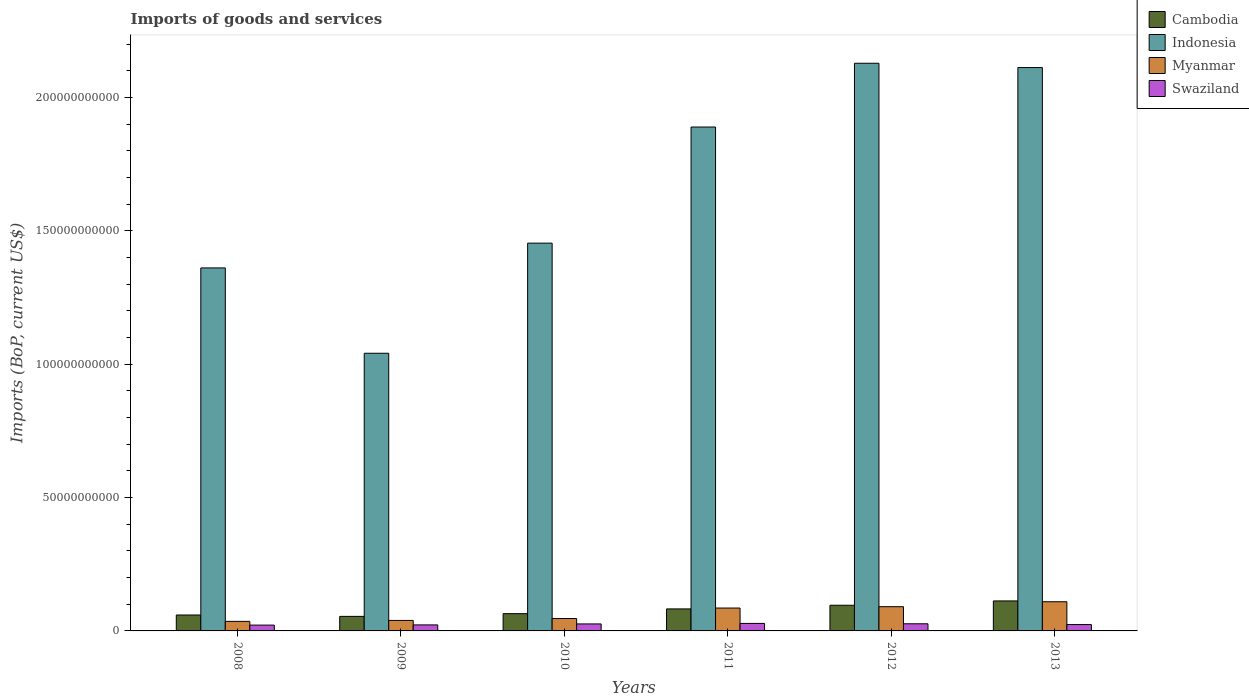How many different coloured bars are there?
Provide a succinct answer. 4. Are the number of bars per tick equal to the number of legend labels?
Your response must be concise. Yes. Are the number of bars on each tick of the X-axis equal?
Provide a succinct answer. Yes. How many bars are there on the 4th tick from the left?
Offer a very short reply. 4. How many bars are there on the 2nd tick from the right?
Provide a short and direct response. 4. What is the label of the 2nd group of bars from the left?
Your answer should be compact. 2009. In how many cases, is the number of bars for a given year not equal to the number of legend labels?
Offer a very short reply. 0. What is the amount spent on imports in Indonesia in 2010?
Offer a terse response. 1.45e+11. Across all years, what is the maximum amount spent on imports in Swaziland?
Provide a short and direct response. 2.82e+09. Across all years, what is the minimum amount spent on imports in Swaziland?
Provide a short and direct response. 2.18e+09. In which year was the amount spent on imports in Indonesia minimum?
Ensure brevity in your answer.  2009. What is the total amount spent on imports in Swaziland in the graph?
Provide a short and direct response. 1.49e+1. What is the difference between the amount spent on imports in Indonesia in 2009 and that in 2012?
Offer a very short reply. -1.09e+11. What is the difference between the amount spent on imports in Swaziland in 2011 and the amount spent on imports in Cambodia in 2009?
Provide a succinct answer. -2.64e+09. What is the average amount spent on imports in Indonesia per year?
Offer a very short reply. 1.66e+11. In the year 2012, what is the difference between the amount spent on imports in Cambodia and amount spent on imports in Indonesia?
Provide a succinct answer. -2.03e+11. In how many years, is the amount spent on imports in Swaziland greater than 210000000000 US$?
Keep it short and to the point. 0. What is the ratio of the amount spent on imports in Swaziland in 2009 to that in 2012?
Keep it short and to the point. 0.84. Is the amount spent on imports in Indonesia in 2010 less than that in 2012?
Make the answer very short. Yes. Is the difference between the amount spent on imports in Cambodia in 2010 and 2012 greater than the difference between the amount spent on imports in Indonesia in 2010 and 2012?
Offer a very short reply. Yes. What is the difference between the highest and the second highest amount spent on imports in Swaziland?
Offer a very short reply. 1.44e+08. What is the difference between the highest and the lowest amount spent on imports in Cambodia?
Give a very brief answer. 5.79e+09. Is the sum of the amount spent on imports in Swaziland in 2010 and 2013 greater than the maximum amount spent on imports in Myanmar across all years?
Your answer should be compact. No. What does the 1st bar from the left in 2013 represents?
Your response must be concise. Cambodia. What does the 1st bar from the right in 2009 represents?
Offer a very short reply. Swaziland. How many years are there in the graph?
Offer a very short reply. 6. What is the difference between two consecutive major ticks on the Y-axis?
Your response must be concise. 5.00e+1. Does the graph contain grids?
Provide a short and direct response. No. How many legend labels are there?
Give a very brief answer. 4. How are the legend labels stacked?
Give a very brief answer. Vertical. What is the title of the graph?
Provide a short and direct response. Imports of goods and services. Does "Mozambique" appear as one of the legend labels in the graph?
Your answer should be compact. No. What is the label or title of the X-axis?
Your answer should be very brief. Years. What is the label or title of the Y-axis?
Your answer should be very brief. Imports (BoP, current US$). What is the Imports (BoP, current US$) in Cambodia in 2008?
Keep it short and to the point. 5.98e+09. What is the Imports (BoP, current US$) in Indonesia in 2008?
Offer a terse response. 1.36e+11. What is the Imports (BoP, current US$) of Myanmar in 2008?
Keep it short and to the point. 3.58e+09. What is the Imports (BoP, current US$) in Swaziland in 2008?
Your answer should be very brief. 2.18e+09. What is the Imports (BoP, current US$) of Cambodia in 2009?
Ensure brevity in your answer.  5.46e+09. What is the Imports (BoP, current US$) in Indonesia in 2009?
Offer a very short reply. 1.04e+11. What is the Imports (BoP, current US$) of Myanmar in 2009?
Offer a terse response. 3.93e+09. What is the Imports (BoP, current US$) of Swaziland in 2009?
Offer a very short reply. 2.26e+09. What is the Imports (BoP, current US$) in Cambodia in 2010?
Make the answer very short. 6.47e+09. What is the Imports (BoP, current US$) in Indonesia in 2010?
Make the answer very short. 1.45e+11. What is the Imports (BoP, current US$) in Myanmar in 2010?
Give a very brief answer. 4.65e+09. What is the Imports (BoP, current US$) of Swaziland in 2010?
Your answer should be very brief. 2.62e+09. What is the Imports (BoP, current US$) of Cambodia in 2011?
Provide a short and direct response. 8.25e+09. What is the Imports (BoP, current US$) in Indonesia in 2011?
Ensure brevity in your answer.  1.89e+11. What is the Imports (BoP, current US$) in Myanmar in 2011?
Your response must be concise. 8.58e+09. What is the Imports (BoP, current US$) of Swaziland in 2011?
Provide a short and direct response. 2.82e+09. What is the Imports (BoP, current US$) of Cambodia in 2012?
Provide a succinct answer. 9.62e+09. What is the Imports (BoP, current US$) in Indonesia in 2012?
Keep it short and to the point. 2.13e+11. What is the Imports (BoP, current US$) in Myanmar in 2012?
Your answer should be compact. 9.09e+09. What is the Imports (BoP, current US$) in Swaziland in 2012?
Offer a very short reply. 2.67e+09. What is the Imports (BoP, current US$) of Cambodia in 2013?
Offer a terse response. 1.12e+1. What is the Imports (BoP, current US$) in Indonesia in 2013?
Provide a succinct answer. 2.11e+11. What is the Imports (BoP, current US$) of Myanmar in 2013?
Provide a short and direct response. 1.09e+1. What is the Imports (BoP, current US$) of Swaziland in 2013?
Provide a short and direct response. 2.39e+09. Across all years, what is the maximum Imports (BoP, current US$) in Cambodia?
Offer a terse response. 1.12e+1. Across all years, what is the maximum Imports (BoP, current US$) of Indonesia?
Give a very brief answer. 2.13e+11. Across all years, what is the maximum Imports (BoP, current US$) in Myanmar?
Your answer should be compact. 1.09e+1. Across all years, what is the maximum Imports (BoP, current US$) in Swaziland?
Ensure brevity in your answer.  2.82e+09. Across all years, what is the minimum Imports (BoP, current US$) of Cambodia?
Keep it short and to the point. 5.46e+09. Across all years, what is the minimum Imports (BoP, current US$) in Indonesia?
Offer a terse response. 1.04e+11. Across all years, what is the minimum Imports (BoP, current US$) in Myanmar?
Offer a very short reply. 3.58e+09. Across all years, what is the minimum Imports (BoP, current US$) of Swaziland?
Ensure brevity in your answer.  2.18e+09. What is the total Imports (BoP, current US$) of Cambodia in the graph?
Give a very brief answer. 4.70e+1. What is the total Imports (BoP, current US$) in Indonesia in the graph?
Ensure brevity in your answer.  9.99e+11. What is the total Imports (BoP, current US$) in Myanmar in the graph?
Offer a terse response. 4.08e+1. What is the total Imports (BoP, current US$) of Swaziland in the graph?
Provide a succinct answer. 1.49e+1. What is the difference between the Imports (BoP, current US$) of Cambodia in 2008 and that in 2009?
Provide a succinct answer. 5.22e+08. What is the difference between the Imports (BoP, current US$) in Indonesia in 2008 and that in 2009?
Make the answer very short. 3.20e+1. What is the difference between the Imports (BoP, current US$) of Myanmar in 2008 and that in 2009?
Keep it short and to the point. -3.50e+08. What is the difference between the Imports (BoP, current US$) in Swaziland in 2008 and that in 2009?
Ensure brevity in your answer.  -7.88e+07. What is the difference between the Imports (BoP, current US$) in Cambodia in 2008 and that in 2010?
Ensure brevity in your answer.  -4.95e+08. What is the difference between the Imports (BoP, current US$) of Indonesia in 2008 and that in 2010?
Ensure brevity in your answer.  -9.29e+09. What is the difference between the Imports (BoP, current US$) of Myanmar in 2008 and that in 2010?
Offer a very short reply. -1.06e+09. What is the difference between the Imports (BoP, current US$) of Swaziland in 2008 and that in 2010?
Your response must be concise. -4.45e+08. What is the difference between the Imports (BoP, current US$) of Cambodia in 2008 and that in 2011?
Your answer should be very brief. -2.27e+09. What is the difference between the Imports (BoP, current US$) in Indonesia in 2008 and that in 2011?
Provide a short and direct response. -5.28e+1. What is the difference between the Imports (BoP, current US$) in Myanmar in 2008 and that in 2011?
Your answer should be compact. -5.00e+09. What is the difference between the Imports (BoP, current US$) of Swaziland in 2008 and that in 2011?
Give a very brief answer. -6.38e+08. What is the difference between the Imports (BoP, current US$) in Cambodia in 2008 and that in 2012?
Give a very brief answer. -3.65e+09. What is the difference between the Imports (BoP, current US$) of Indonesia in 2008 and that in 2012?
Ensure brevity in your answer.  -7.68e+1. What is the difference between the Imports (BoP, current US$) of Myanmar in 2008 and that in 2012?
Your answer should be very brief. -5.51e+09. What is the difference between the Imports (BoP, current US$) of Swaziland in 2008 and that in 2012?
Provide a short and direct response. -4.94e+08. What is the difference between the Imports (BoP, current US$) of Cambodia in 2008 and that in 2013?
Keep it short and to the point. -5.27e+09. What is the difference between the Imports (BoP, current US$) of Indonesia in 2008 and that in 2013?
Give a very brief answer. -7.51e+1. What is the difference between the Imports (BoP, current US$) in Myanmar in 2008 and that in 2013?
Ensure brevity in your answer.  -7.36e+09. What is the difference between the Imports (BoP, current US$) in Swaziland in 2008 and that in 2013?
Offer a very short reply. -2.14e+08. What is the difference between the Imports (BoP, current US$) of Cambodia in 2009 and that in 2010?
Your answer should be very brief. -1.02e+09. What is the difference between the Imports (BoP, current US$) in Indonesia in 2009 and that in 2010?
Ensure brevity in your answer.  -4.13e+1. What is the difference between the Imports (BoP, current US$) in Myanmar in 2009 and that in 2010?
Your response must be concise. -7.14e+08. What is the difference between the Imports (BoP, current US$) in Swaziland in 2009 and that in 2010?
Provide a short and direct response. -3.66e+08. What is the difference between the Imports (BoP, current US$) of Cambodia in 2009 and that in 2011?
Your answer should be very brief. -2.80e+09. What is the difference between the Imports (BoP, current US$) of Indonesia in 2009 and that in 2011?
Keep it short and to the point. -8.48e+1. What is the difference between the Imports (BoP, current US$) of Myanmar in 2009 and that in 2011?
Ensure brevity in your answer.  -4.65e+09. What is the difference between the Imports (BoP, current US$) of Swaziland in 2009 and that in 2011?
Your answer should be compact. -5.59e+08. What is the difference between the Imports (BoP, current US$) of Cambodia in 2009 and that in 2012?
Provide a succinct answer. -4.17e+09. What is the difference between the Imports (BoP, current US$) in Indonesia in 2009 and that in 2012?
Your answer should be very brief. -1.09e+11. What is the difference between the Imports (BoP, current US$) of Myanmar in 2009 and that in 2012?
Give a very brief answer. -5.16e+09. What is the difference between the Imports (BoP, current US$) in Swaziland in 2009 and that in 2012?
Your response must be concise. -4.15e+08. What is the difference between the Imports (BoP, current US$) in Cambodia in 2009 and that in 2013?
Keep it short and to the point. -5.79e+09. What is the difference between the Imports (BoP, current US$) in Indonesia in 2009 and that in 2013?
Provide a succinct answer. -1.07e+11. What is the difference between the Imports (BoP, current US$) in Myanmar in 2009 and that in 2013?
Keep it short and to the point. -7.01e+09. What is the difference between the Imports (BoP, current US$) in Swaziland in 2009 and that in 2013?
Ensure brevity in your answer.  -1.35e+08. What is the difference between the Imports (BoP, current US$) of Cambodia in 2010 and that in 2011?
Make the answer very short. -1.78e+09. What is the difference between the Imports (BoP, current US$) of Indonesia in 2010 and that in 2011?
Give a very brief answer. -4.36e+1. What is the difference between the Imports (BoP, current US$) in Myanmar in 2010 and that in 2011?
Offer a terse response. -3.93e+09. What is the difference between the Imports (BoP, current US$) in Swaziland in 2010 and that in 2011?
Your answer should be compact. -1.93e+08. What is the difference between the Imports (BoP, current US$) of Cambodia in 2010 and that in 2012?
Give a very brief answer. -3.15e+09. What is the difference between the Imports (BoP, current US$) of Indonesia in 2010 and that in 2012?
Keep it short and to the point. -6.75e+1. What is the difference between the Imports (BoP, current US$) in Myanmar in 2010 and that in 2012?
Offer a terse response. -4.44e+09. What is the difference between the Imports (BoP, current US$) in Swaziland in 2010 and that in 2012?
Your response must be concise. -4.94e+07. What is the difference between the Imports (BoP, current US$) in Cambodia in 2010 and that in 2013?
Make the answer very short. -4.77e+09. What is the difference between the Imports (BoP, current US$) of Indonesia in 2010 and that in 2013?
Give a very brief answer. -6.58e+1. What is the difference between the Imports (BoP, current US$) of Myanmar in 2010 and that in 2013?
Your answer should be compact. -6.30e+09. What is the difference between the Imports (BoP, current US$) of Swaziland in 2010 and that in 2013?
Your answer should be compact. 2.31e+08. What is the difference between the Imports (BoP, current US$) of Cambodia in 2011 and that in 2012?
Give a very brief answer. -1.37e+09. What is the difference between the Imports (BoP, current US$) of Indonesia in 2011 and that in 2012?
Make the answer very short. -2.39e+1. What is the difference between the Imports (BoP, current US$) in Myanmar in 2011 and that in 2012?
Keep it short and to the point. -5.07e+08. What is the difference between the Imports (BoP, current US$) in Swaziland in 2011 and that in 2012?
Keep it short and to the point. 1.44e+08. What is the difference between the Imports (BoP, current US$) of Cambodia in 2011 and that in 2013?
Provide a short and direct response. -2.99e+09. What is the difference between the Imports (BoP, current US$) of Indonesia in 2011 and that in 2013?
Ensure brevity in your answer.  -2.23e+1. What is the difference between the Imports (BoP, current US$) in Myanmar in 2011 and that in 2013?
Make the answer very short. -2.36e+09. What is the difference between the Imports (BoP, current US$) of Swaziland in 2011 and that in 2013?
Offer a terse response. 4.24e+08. What is the difference between the Imports (BoP, current US$) in Cambodia in 2012 and that in 2013?
Give a very brief answer. -1.62e+09. What is the difference between the Imports (BoP, current US$) of Indonesia in 2012 and that in 2013?
Offer a very short reply. 1.62e+09. What is the difference between the Imports (BoP, current US$) in Myanmar in 2012 and that in 2013?
Your response must be concise. -1.86e+09. What is the difference between the Imports (BoP, current US$) of Swaziland in 2012 and that in 2013?
Your answer should be very brief. 2.81e+08. What is the difference between the Imports (BoP, current US$) of Cambodia in 2008 and the Imports (BoP, current US$) of Indonesia in 2009?
Your answer should be very brief. -9.82e+1. What is the difference between the Imports (BoP, current US$) in Cambodia in 2008 and the Imports (BoP, current US$) in Myanmar in 2009?
Offer a terse response. 2.04e+09. What is the difference between the Imports (BoP, current US$) in Cambodia in 2008 and the Imports (BoP, current US$) in Swaziland in 2009?
Provide a short and direct response. 3.72e+09. What is the difference between the Imports (BoP, current US$) of Indonesia in 2008 and the Imports (BoP, current US$) of Myanmar in 2009?
Your response must be concise. 1.32e+11. What is the difference between the Imports (BoP, current US$) of Indonesia in 2008 and the Imports (BoP, current US$) of Swaziland in 2009?
Provide a succinct answer. 1.34e+11. What is the difference between the Imports (BoP, current US$) of Myanmar in 2008 and the Imports (BoP, current US$) of Swaziland in 2009?
Make the answer very short. 1.32e+09. What is the difference between the Imports (BoP, current US$) of Cambodia in 2008 and the Imports (BoP, current US$) of Indonesia in 2010?
Your answer should be very brief. -1.39e+11. What is the difference between the Imports (BoP, current US$) of Cambodia in 2008 and the Imports (BoP, current US$) of Myanmar in 2010?
Offer a terse response. 1.33e+09. What is the difference between the Imports (BoP, current US$) in Cambodia in 2008 and the Imports (BoP, current US$) in Swaziland in 2010?
Keep it short and to the point. 3.35e+09. What is the difference between the Imports (BoP, current US$) in Indonesia in 2008 and the Imports (BoP, current US$) in Myanmar in 2010?
Offer a terse response. 1.31e+11. What is the difference between the Imports (BoP, current US$) in Indonesia in 2008 and the Imports (BoP, current US$) in Swaziland in 2010?
Give a very brief answer. 1.34e+11. What is the difference between the Imports (BoP, current US$) of Myanmar in 2008 and the Imports (BoP, current US$) of Swaziland in 2010?
Make the answer very short. 9.58e+08. What is the difference between the Imports (BoP, current US$) in Cambodia in 2008 and the Imports (BoP, current US$) in Indonesia in 2011?
Your answer should be compact. -1.83e+11. What is the difference between the Imports (BoP, current US$) of Cambodia in 2008 and the Imports (BoP, current US$) of Myanmar in 2011?
Provide a succinct answer. -2.60e+09. What is the difference between the Imports (BoP, current US$) in Cambodia in 2008 and the Imports (BoP, current US$) in Swaziland in 2011?
Your answer should be compact. 3.16e+09. What is the difference between the Imports (BoP, current US$) in Indonesia in 2008 and the Imports (BoP, current US$) in Myanmar in 2011?
Provide a short and direct response. 1.28e+11. What is the difference between the Imports (BoP, current US$) in Indonesia in 2008 and the Imports (BoP, current US$) in Swaziland in 2011?
Make the answer very short. 1.33e+11. What is the difference between the Imports (BoP, current US$) in Myanmar in 2008 and the Imports (BoP, current US$) in Swaziland in 2011?
Offer a very short reply. 7.65e+08. What is the difference between the Imports (BoP, current US$) of Cambodia in 2008 and the Imports (BoP, current US$) of Indonesia in 2012?
Your answer should be compact. -2.07e+11. What is the difference between the Imports (BoP, current US$) of Cambodia in 2008 and the Imports (BoP, current US$) of Myanmar in 2012?
Make the answer very short. -3.11e+09. What is the difference between the Imports (BoP, current US$) in Cambodia in 2008 and the Imports (BoP, current US$) in Swaziland in 2012?
Your answer should be very brief. 3.30e+09. What is the difference between the Imports (BoP, current US$) in Indonesia in 2008 and the Imports (BoP, current US$) in Myanmar in 2012?
Provide a succinct answer. 1.27e+11. What is the difference between the Imports (BoP, current US$) of Indonesia in 2008 and the Imports (BoP, current US$) of Swaziland in 2012?
Your response must be concise. 1.33e+11. What is the difference between the Imports (BoP, current US$) in Myanmar in 2008 and the Imports (BoP, current US$) in Swaziland in 2012?
Your answer should be very brief. 9.08e+08. What is the difference between the Imports (BoP, current US$) in Cambodia in 2008 and the Imports (BoP, current US$) in Indonesia in 2013?
Keep it short and to the point. -2.05e+11. What is the difference between the Imports (BoP, current US$) of Cambodia in 2008 and the Imports (BoP, current US$) of Myanmar in 2013?
Keep it short and to the point. -4.97e+09. What is the difference between the Imports (BoP, current US$) in Cambodia in 2008 and the Imports (BoP, current US$) in Swaziland in 2013?
Offer a terse response. 3.58e+09. What is the difference between the Imports (BoP, current US$) of Indonesia in 2008 and the Imports (BoP, current US$) of Myanmar in 2013?
Your answer should be compact. 1.25e+11. What is the difference between the Imports (BoP, current US$) in Indonesia in 2008 and the Imports (BoP, current US$) in Swaziland in 2013?
Provide a succinct answer. 1.34e+11. What is the difference between the Imports (BoP, current US$) of Myanmar in 2008 and the Imports (BoP, current US$) of Swaziland in 2013?
Give a very brief answer. 1.19e+09. What is the difference between the Imports (BoP, current US$) of Cambodia in 2009 and the Imports (BoP, current US$) of Indonesia in 2010?
Provide a short and direct response. -1.40e+11. What is the difference between the Imports (BoP, current US$) of Cambodia in 2009 and the Imports (BoP, current US$) of Myanmar in 2010?
Your response must be concise. 8.09e+08. What is the difference between the Imports (BoP, current US$) of Cambodia in 2009 and the Imports (BoP, current US$) of Swaziland in 2010?
Make the answer very short. 2.83e+09. What is the difference between the Imports (BoP, current US$) in Indonesia in 2009 and the Imports (BoP, current US$) in Myanmar in 2010?
Provide a succinct answer. 9.95e+1. What is the difference between the Imports (BoP, current US$) in Indonesia in 2009 and the Imports (BoP, current US$) in Swaziland in 2010?
Your answer should be very brief. 1.02e+11. What is the difference between the Imports (BoP, current US$) in Myanmar in 2009 and the Imports (BoP, current US$) in Swaziland in 2010?
Offer a terse response. 1.31e+09. What is the difference between the Imports (BoP, current US$) in Cambodia in 2009 and the Imports (BoP, current US$) in Indonesia in 2011?
Make the answer very short. -1.84e+11. What is the difference between the Imports (BoP, current US$) in Cambodia in 2009 and the Imports (BoP, current US$) in Myanmar in 2011?
Give a very brief answer. -3.13e+09. What is the difference between the Imports (BoP, current US$) of Cambodia in 2009 and the Imports (BoP, current US$) of Swaziland in 2011?
Your answer should be very brief. 2.64e+09. What is the difference between the Imports (BoP, current US$) of Indonesia in 2009 and the Imports (BoP, current US$) of Myanmar in 2011?
Your answer should be compact. 9.55e+1. What is the difference between the Imports (BoP, current US$) of Indonesia in 2009 and the Imports (BoP, current US$) of Swaziland in 2011?
Your answer should be compact. 1.01e+11. What is the difference between the Imports (BoP, current US$) in Myanmar in 2009 and the Imports (BoP, current US$) in Swaziland in 2011?
Your answer should be very brief. 1.11e+09. What is the difference between the Imports (BoP, current US$) of Cambodia in 2009 and the Imports (BoP, current US$) of Indonesia in 2012?
Provide a short and direct response. -2.07e+11. What is the difference between the Imports (BoP, current US$) of Cambodia in 2009 and the Imports (BoP, current US$) of Myanmar in 2012?
Your response must be concise. -3.63e+09. What is the difference between the Imports (BoP, current US$) in Cambodia in 2009 and the Imports (BoP, current US$) in Swaziland in 2012?
Give a very brief answer. 2.78e+09. What is the difference between the Imports (BoP, current US$) in Indonesia in 2009 and the Imports (BoP, current US$) in Myanmar in 2012?
Your answer should be very brief. 9.50e+1. What is the difference between the Imports (BoP, current US$) in Indonesia in 2009 and the Imports (BoP, current US$) in Swaziland in 2012?
Provide a succinct answer. 1.01e+11. What is the difference between the Imports (BoP, current US$) of Myanmar in 2009 and the Imports (BoP, current US$) of Swaziland in 2012?
Ensure brevity in your answer.  1.26e+09. What is the difference between the Imports (BoP, current US$) of Cambodia in 2009 and the Imports (BoP, current US$) of Indonesia in 2013?
Keep it short and to the point. -2.06e+11. What is the difference between the Imports (BoP, current US$) of Cambodia in 2009 and the Imports (BoP, current US$) of Myanmar in 2013?
Ensure brevity in your answer.  -5.49e+09. What is the difference between the Imports (BoP, current US$) of Cambodia in 2009 and the Imports (BoP, current US$) of Swaziland in 2013?
Your response must be concise. 3.06e+09. What is the difference between the Imports (BoP, current US$) of Indonesia in 2009 and the Imports (BoP, current US$) of Myanmar in 2013?
Ensure brevity in your answer.  9.32e+1. What is the difference between the Imports (BoP, current US$) of Indonesia in 2009 and the Imports (BoP, current US$) of Swaziland in 2013?
Your answer should be compact. 1.02e+11. What is the difference between the Imports (BoP, current US$) in Myanmar in 2009 and the Imports (BoP, current US$) in Swaziland in 2013?
Keep it short and to the point. 1.54e+09. What is the difference between the Imports (BoP, current US$) in Cambodia in 2010 and the Imports (BoP, current US$) in Indonesia in 2011?
Your answer should be compact. -1.83e+11. What is the difference between the Imports (BoP, current US$) of Cambodia in 2010 and the Imports (BoP, current US$) of Myanmar in 2011?
Make the answer very short. -2.11e+09. What is the difference between the Imports (BoP, current US$) of Cambodia in 2010 and the Imports (BoP, current US$) of Swaziland in 2011?
Provide a succinct answer. 3.65e+09. What is the difference between the Imports (BoP, current US$) in Indonesia in 2010 and the Imports (BoP, current US$) in Myanmar in 2011?
Your answer should be very brief. 1.37e+11. What is the difference between the Imports (BoP, current US$) of Indonesia in 2010 and the Imports (BoP, current US$) of Swaziland in 2011?
Make the answer very short. 1.43e+11. What is the difference between the Imports (BoP, current US$) in Myanmar in 2010 and the Imports (BoP, current US$) in Swaziland in 2011?
Give a very brief answer. 1.83e+09. What is the difference between the Imports (BoP, current US$) in Cambodia in 2010 and the Imports (BoP, current US$) in Indonesia in 2012?
Keep it short and to the point. -2.06e+11. What is the difference between the Imports (BoP, current US$) in Cambodia in 2010 and the Imports (BoP, current US$) in Myanmar in 2012?
Your answer should be very brief. -2.62e+09. What is the difference between the Imports (BoP, current US$) of Cambodia in 2010 and the Imports (BoP, current US$) of Swaziland in 2012?
Your answer should be very brief. 3.80e+09. What is the difference between the Imports (BoP, current US$) of Indonesia in 2010 and the Imports (BoP, current US$) of Myanmar in 2012?
Your answer should be compact. 1.36e+11. What is the difference between the Imports (BoP, current US$) of Indonesia in 2010 and the Imports (BoP, current US$) of Swaziland in 2012?
Your response must be concise. 1.43e+11. What is the difference between the Imports (BoP, current US$) in Myanmar in 2010 and the Imports (BoP, current US$) in Swaziland in 2012?
Your response must be concise. 1.97e+09. What is the difference between the Imports (BoP, current US$) in Cambodia in 2010 and the Imports (BoP, current US$) in Indonesia in 2013?
Your answer should be compact. -2.05e+11. What is the difference between the Imports (BoP, current US$) in Cambodia in 2010 and the Imports (BoP, current US$) in Myanmar in 2013?
Give a very brief answer. -4.47e+09. What is the difference between the Imports (BoP, current US$) of Cambodia in 2010 and the Imports (BoP, current US$) of Swaziland in 2013?
Your answer should be compact. 4.08e+09. What is the difference between the Imports (BoP, current US$) in Indonesia in 2010 and the Imports (BoP, current US$) in Myanmar in 2013?
Offer a terse response. 1.34e+11. What is the difference between the Imports (BoP, current US$) in Indonesia in 2010 and the Imports (BoP, current US$) in Swaziland in 2013?
Make the answer very short. 1.43e+11. What is the difference between the Imports (BoP, current US$) in Myanmar in 2010 and the Imports (BoP, current US$) in Swaziland in 2013?
Make the answer very short. 2.25e+09. What is the difference between the Imports (BoP, current US$) of Cambodia in 2011 and the Imports (BoP, current US$) of Indonesia in 2012?
Your response must be concise. -2.05e+11. What is the difference between the Imports (BoP, current US$) of Cambodia in 2011 and the Imports (BoP, current US$) of Myanmar in 2012?
Ensure brevity in your answer.  -8.36e+08. What is the difference between the Imports (BoP, current US$) of Cambodia in 2011 and the Imports (BoP, current US$) of Swaziland in 2012?
Ensure brevity in your answer.  5.58e+09. What is the difference between the Imports (BoP, current US$) of Indonesia in 2011 and the Imports (BoP, current US$) of Myanmar in 2012?
Your answer should be very brief. 1.80e+11. What is the difference between the Imports (BoP, current US$) of Indonesia in 2011 and the Imports (BoP, current US$) of Swaziland in 2012?
Your answer should be very brief. 1.86e+11. What is the difference between the Imports (BoP, current US$) of Myanmar in 2011 and the Imports (BoP, current US$) of Swaziland in 2012?
Ensure brevity in your answer.  5.91e+09. What is the difference between the Imports (BoP, current US$) of Cambodia in 2011 and the Imports (BoP, current US$) of Indonesia in 2013?
Give a very brief answer. -2.03e+11. What is the difference between the Imports (BoP, current US$) in Cambodia in 2011 and the Imports (BoP, current US$) in Myanmar in 2013?
Ensure brevity in your answer.  -2.69e+09. What is the difference between the Imports (BoP, current US$) of Cambodia in 2011 and the Imports (BoP, current US$) of Swaziland in 2013?
Make the answer very short. 5.86e+09. What is the difference between the Imports (BoP, current US$) in Indonesia in 2011 and the Imports (BoP, current US$) in Myanmar in 2013?
Offer a terse response. 1.78e+11. What is the difference between the Imports (BoP, current US$) in Indonesia in 2011 and the Imports (BoP, current US$) in Swaziland in 2013?
Give a very brief answer. 1.87e+11. What is the difference between the Imports (BoP, current US$) of Myanmar in 2011 and the Imports (BoP, current US$) of Swaziland in 2013?
Your response must be concise. 6.19e+09. What is the difference between the Imports (BoP, current US$) of Cambodia in 2012 and the Imports (BoP, current US$) of Indonesia in 2013?
Your response must be concise. -2.02e+11. What is the difference between the Imports (BoP, current US$) in Cambodia in 2012 and the Imports (BoP, current US$) in Myanmar in 2013?
Provide a succinct answer. -1.32e+09. What is the difference between the Imports (BoP, current US$) in Cambodia in 2012 and the Imports (BoP, current US$) in Swaziland in 2013?
Provide a succinct answer. 7.23e+09. What is the difference between the Imports (BoP, current US$) in Indonesia in 2012 and the Imports (BoP, current US$) in Myanmar in 2013?
Ensure brevity in your answer.  2.02e+11. What is the difference between the Imports (BoP, current US$) of Indonesia in 2012 and the Imports (BoP, current US$) of Swaziland in 2013?
Provide a short and direct response. 2.10e+11. What is the difference between the Imports (BoP, current US$) of Myanmar in 2012 and the Imports (BoP, current US$) of Swaziland in 2013?
Provide a short and direct response. 6.69e+09. What is the average Imports (BoP, current US$) of Cambodia per year?
Make the answer very short. 7.84e+09. What is the average Imports (BoP, current US$) of Indonesia per year?
Make the answer very short. 1.66e+11. What is the average Imports (BoP, current US$) of Myanmar per year?
Your answer should be compact. 6.80e+09. What is the average Imports (BoP, current US$) of Swaziland per year?
Provide a succinct answer. 2.49e+09. In the year 2008, what is the difference between the Imports (BoP, current US$) of Cambodia and Imports (BoP, current US$) of Indonesia?
Ensure brevity in your answer.  -1.30e+11. In the year 2008, what is the difference between the Imports (BoP, current US$) in Cambodia and Imports (BoP, current US$) in Myanmar?
Provide a succinct answer. 2.39e+09. In the year 2008, what is the difference between the Imports (BoP, current US$) in Cambodia and Imports (BoP, current US$) in Swaziland?
Your answer should be very brief. 3.80e+09. In the year 2008, what is the difference between the Imports (BoP, current US$) of Indonesia and Imports (BoP, current US$) of Myanmar?
Make the answer very short. 1.33e+11. In the year 2008, what is the difference between the Imports (BoP, current US$) of Indonesia and Imports (BoP, current US$) of Swaziland?
Your answer should be compact. 1.34e+11. In the year 2008, what is the difference between the Imports (BoP, current US$) in Myanmar and Imports (BoP, current US$) in Swaziland?
Keep it short and to the point. 1.40e+09. In the year 2009, what is the difference between the Imports (BoP, current US$) of Cambodia and Imports (BoP, current US$) of Indonesia?
Ensure brevity in your answer.  -9.87e+1. In the year 2009, what is the difference between the Imports (BoP, current US$) in Cambodia and Imports (BoP, current US$) in Myanmar?
Offer a very short reply. 1.52e+09. In the year 2009, what is the difference between the Imports (BoP, current US$) of Cambodia and Imports (BoP, current US$) of Swaziland?
Your answer should be compact. 3.20e+09. In the year 2009, what is the difference between the Imports (BoP, current US$) in Indonesia and Imports (BoP, current US$) in Myanmar?
Ensure brevity in your answer.  1.00e+11. In the year 2009, what is the difference between the Imports (BoP, current US$) of Indonesia and Imports (BoP, current US$) of Swaziland?
Offer a very short reply. 1.02e+11. In the year 2009, what is the difference between the Imports (BoP, current US$) in Myanmar and Imports (BoP, current US$) in Swaziland?
Your response must be concise. 1.67e+09. In the year 2010, what is the difference between the Imports (BoP, current US$) in Cambodia and Imports (BoP, current US$) in Indonesia?
Make the answer very short. -1.39e+11. In the year 2010, what is the difference between the Imports (BoP, current US$) in Cambodia and Imports (BoP, current US$) in Myanmar?
Your answer should be very brief. 1.83e+09. In the year 2010, what is the difference between the Imports (BoP, current US$) in Cambodia and Imports (BoP, current US$) in Swaziland?
Make the answer very short. 3.85e+09. In the year 2010, what is the difference between the Imports (BoP, current US$) in Indonesia and Imports (BoP, current US$) in Myanmar?
Your response must be concise. 1.41e+11. In the year 2010, what is the difference between the Imports (BoP, current US$) in Indonesia and Imports (BoP, current US$) in Swaziland?
Make the answer very short. 1.43e+11. In the year 2010, what is the difference between the Imports (BoP, current US$) in Myanmar and Imports (BoP, current US$) in Swaziland?
Ensure brevity in your answer.  2.02e+09. In the year 2011, what is the difference between the Imports (BoP, current US$) in Cambodia and Imports (BoP, current US$) in Indonesia?
Your answer should be very brief. -1.81e+11. In the year 2011, what is the difference between the Imports (BoP, current US$) in Cambodia and Imports (BoP, current US$) in Myanmar?
Your response must be concise. -3.30e+08. In the year 2011, what is the difference between the Imports (BoP, current US$) in Cambodia and Imports (BoP, current US$) in Swaziland?
Your response must be concise. 5.43e+09. In the year 2011, what is the difference between the Imports (BoP, current US$) in Indonesia and Imports (BoP, current US$) in Myanmar?
Offer a very short reply. 1.80e+11. In the year 2011, what is the difference between the Imports (BoP, current US$) of Indonesia and Imports (BoP, current US$) of Swaziland?
Your answer should be very brief. 1.86e+11. In the year 2011, what is the difference between the Imports (BoP, current US$) in Myanmar and Imports (BoP, current US$) in Swaziland?
Provide a short and direct response. 5.76e+09. In the year 2012, what is the difference between the Imports (BoP, current US$) of Cambodia and Imports (BoP, current US$) of Indonesia?
Give a very brief answer. -2.03e+11. In the year 2012, what is the difference between the Imports (BoP, current US$) of Cambodia and Imports (BoP, current US$) of Myanmar?
Give a very brief answer. 5.36e+08. In the year 2012, what is the difference between the Imports (BoP, current US$) of Cambodia and Imports (BoP, current US$) of Swaziland?
Keep it short and to the point. 6.95e+09. In the year 2012, what is the difference between the Imports (BoP, current US$) of Indonesia and Imports (BoP, current US$) of Myanmar?
Give a very brief answer. 2.04e+11. In the year 2012, what is the difference between the Imports (BoP, current US$) in Indonesia and Imports (BoP, current US$) in Swaziland?
Keep it short and to the point. 2.10e+11. In the year 2012, what is the difference between the Imports (BoP, current US$) in Myanmar and Imports (BoP, current US$) in Swaziland?
Ensure brevity in your answer.  6.41e+09. In the year 2013, what is the difference between the Imports (BoP, current US$) of Cambodia and Imports (BoP, current US$) of Indonesia?
Give a very brief answer. -2.00e+11. In the year 2013, what is the difference between the Imports (BoP, current US$) in Cambodia and Imports (BoP, current US$) in Myanmar?
Your response must be concise. 3.02e+08. In the year 2013, what is the difference between the Imports (BoP, current US$) in Cambodia and Imports (BoP, current US$) in Swaziland?
Offer a very short reply. 8.85e+09. In the year 2013, what is the difference between the Imports (BoP, current US$) in Indonesia and Imports (BoP, current US$) in Myanmar?
Offer a terse response. 2.00e+11. In the year 2013, what is the difference between the Imports (BoP, current US$) of Indonesia and Imports (BoP, current US$) of Swaziland?
Your answer should be very brief. 2.09e+11. In the year 2013, what is the difference between the Imports (BoP, current US$) of Myanmar and Imports (BoP, current US$) of Swaziland?
Give a very brief answer. 8.55e+09. What is the ratio of the Imports (BoP, current US$) in Cambodia in 2008 to that in 2009?
Your answer should be very brief. 1.1. What is the ratio of the Imports (BoP, current US$) of Indonesia in 2008 to that in 2009?
Give a very brief answer. 1.31. What is the ratio of the Imports (BoP, current US$) of Myanmar in 2008 to that in 2009?
Keep it short and to the point. 0.91. What is the ratio of the Imports (BoP, current US$) in Swaziland in 2008 to that in 2009?
Your answer should be compact. 0.97. What is the ratio of the Imports (BoP, current US$) in Cambodia in 2008 to that in 2010?
Keep it short and to the point. 0.92. What is the ratio of the Imports (BoP, current US$) in Indonesia in 2008 to that in 2010?
Give a very brief answer. 0.94. What is the ratio of the Imports (BoP, current US$) of Myanmar in 2008 to that in 2010?
Offer a terse response. 0.77. What is the ratio of the Imports (BoP, current US$) of Swaziland in 2008 to that in 2010?
Make the answer very short. 0.83. What is the ratio of the Imports (BoP, current US$) of Cambodia in 2008 to that in 2011?
Give a very brief answer. 0.72. What is the ratio of the Imports (BoP, current US$) in Indonesia in 2008 to that in 2011?
Ensure brevity in your answer.  0.72. What is the ratio of the Imports (BoP, current US$) in Myanmar in 2008 to that in 2011?
Provide a succinct answer. 0.42. What is the ratio of the Imports (BoP, current US$) in Swaziland in 2008 to that in 2011?
Offer a terse response. 0.77. What is the ratio of the Imports (BoP, current US$) of Cambodia in 2008 to that in 2012?
Your answer should be compact. 0.62. What is the ratio of the Imports (BoP, current US$) of Indonesia in 2008 to that in 2012?
Offer a very short reply. 0.64. What is the ratio of the Imports (BoP, current US$) in Myanmar in 2008 to that in 2012?
Ensure brevity in your answer.  0.39. What is the ratio of the Imports (BoP, current US$) of Swaziland in 2008 to that in 2012?
Give a very brief answer. 0.82. What is the ratio of the Imports (BoP, current US$) in Cambodia in 2008 to that in 2013?
Your answer should be very brief. 0.53. What is the ratio of the Imports (BoP, current US$) of Indonesia in 2008 to that in 2013?
Your answer should be very brief. 0.64. What is the ratio of the Imports (BoP, current US$) in Myanmar in 2008 to that in 2013?
Offer a very short reply. 0.33. What is the ratio of the Imports (BoP, current US$) of Swaziland in 2008 to that in 2013?
Offer a very short reply. 0.91. What is the ratio of the Imports (BoP, current US$) of Cambodia in 2009 to that in 2010?
Ensure brevity in your answer.  0.84. What is the ratio of the Imports (BoP, current US$) of Indonesia in 2009 to that in 2010?
Ensure brevity in your answer.  0.72. What is the ratio of the Imports (BoP, current US$) in Myanmar in 2009 to that in 2010?
Ensure brevity in your answer.  0.85. What is the ratio of the Imports (BoP, current US$) of Swaziland in 2009 to that in 2010?
Offer a terse response. 0.86. What is the ratio of the Imports (BoP, current US$) in Cambodia in 2009 to that in 2011?
Offer a very short reply. 0.66. What is the ratio of the Imports (BoP, current US$) of Indonesia in 2009 to that in 2011?
Keep it short and to the point. 0.55. What is the ratio of the Imports (BoP, current US$) of Myanmar in 2009 to that in 2011?
Offer a very short reply. 0.46. What is the ratio of the Imports (BoP, current US$) of Swaziland in 2009 to that in 2011?
Make the answer very short. 0.8. What is the ratio of the Imports (BoP, current US$) of Cambodia in 2009 to that in 2012?
Your answer should be compact. 0.57. What is the ratio of the Imports (BoP, current US$) of Indonesia in 2009 to that in 2012?
Your answer should be very brief. 0.49. What is the ratio of the Imports (BoP, current US$) of Myanmar in 2009 to that in 2012?
Make the answer very short. 0.43. What is the ratio of the Imports (BoP, current US$) in Swaziland in 2009 to that in 2012?
Your response must be concise. 0.84. What is the ratio of the Imports (BoP, current US$) of Cambodia in 2009 to that in 2013?
Provide a short and direct response. 0.49. What is the ratio of the Imports (BoP, current US$) in Indonesia in 2009 to that in 2013?
Provide a short and direct response. 0.49. What is the ratio of the Imports (BoP, current US$) in Myanmar in 2009 to that in 2013?
Provide a short and direct response. 0.36. What is the ratio of the Imports (BoP, current US$) in Swaziland in 2009 to that in 2013?
Offer a terse response. 0.94. What is the ratio of the Imports (BoP, current US$) in Cambodia in 2010 to that in 2011?
Provide a succinct answer. 0.78. What is the ratio of the Imports (BoP, current US$) in Indonesia in 2010 to that in 2011?
Provide a short and direct response. 0.77. What is the ratio of the Imports (BoP, current US$) of Myanmar in 2010 to that in 2011?
Ensure brevity in your answer.  0.54. What is the ratio of the Imports (BoP, current US$) of Swaziland in 2010 to that in 2011?
Provide a succinct answer. 0.93. What is the ratio of the Imports (BoP, current US$) in Cambodia in 2010 to that in 2012?
Keep it short and to the point. 0.67. What is the ratio of the Imports (BoP, current US$) in Indonesia in 2010 to that in 2012?
Offer a very short reply. 0.68. What is the ratio of the Imports (BoP, current US$) in Myanmar in 2010 to that in 2012?
Your answer should be very brief. 0.51. What is the ratio of the Imports (BoP, current US$) in Swaziland in 2010 to that in 2012?
Your answer should be compact. 0.98. What is the ratio of the Imports (BoP, current US$) in Cambodia in 2010 to that in 2013?
Make the answer very short. 0.58. What is the ratio of the Imports (BoP, current US$) of Indonesia in 2010 to that in 2013?
Provide a short and direct response. 0.69. What is the ratio of the Imports (BoP, current US$) in Myanmar in 2010 to that in 2013?
Offer a terse response. 0.42. What is the ratio of the Imports (BoP, current US$) of Swaziland in 2010 to that in 2013?
Your answer should be very brief. 1.1. What is the ratio of the Imports (BoP, current US$) in Cambodia in 2011 to that in 2012?
Provide a short and direct response. 0.86. What is the ratio of the Imports (BoP, current US$) in Indonesia in 2011 to that in 2012?
Your response must be concise. 0.89. What is the ratio of the Imports (BoP, current US$) in Myanmar in 2011 to that in 2012?
Provide a succinct answer. 0.94. What is the ratio of the Imports (BoP, current US$) of Swaziland in 2011 to that in 2012?
Make the answer very short. 1.05. What is the ratio of the Imports (BoP, current US$) in Cambodia in 2011 to that in 2013?
Provide a short and direct response. 0.73. What is the ratio of the Imports (BoP, current US$) of Indonesia in 2011 to that in 2013?
Provide a succinct answer. 0.89. What is the ratio of the Imports (BoP, current US$) in Myanmar in 2011 to that in 2013?
Your answer should be compact. 0.78. What is the ratio of the Imports (BoP, current US$) in Swaziland in 2011 to that in 2013?
Make the answer very short. 1.18. What is the ratio of the Imports (BoP, current US$) in Cambodia in 2012 to that in 2013?
Offer a terse response. 0.86. What is the ratio of the Imports (BoP, current US$) in Indonesia in 2012 to that in 2013?
Your answer should be very brief. 1.01. What is the ratio of the Imports (BoP, current US$) in Myanmar in 2012 to that in 2013?
Your answer should be compact. 0.83. What is the ratio of the Imports (BoP, current US$) of Swaziland in 2012 to that in 2013?
Ensure brevity in your answer.  1.12. What is the difference between the highest and the second highest Imports (BoP, current US$) in Cambodia?
Ensure brevity in your answer.  1.62e+09. What is the difference between the highest and the second highest Imports (BoP, current US$) of Indonesia?
Keep it short and to the point. 1.62e+09. What is the difference between the highest and the second highest Imports (BoP, current US$) of Myanmar?
Give a very brief answer. 1.86e+09. What is the difference between the highest and the second highest Imports (BoP, current US$) in Swaziland?
Keep it short and to the point. 1.44e+08. What is the difference between the highest and the lowest Imports (BoP, current US$) of Cambodia?
Your answer should be very brief. 5.79e+09. What is the difference between the highest and the lowest Imports (BoP, current US$) in Indonesia?
Keep it short and to the point. 1.09e+11. What is the difference between the highest and the lowest Imports (BoP, current US$) in Myanmar?
Offer a very short reply. 7.36e+09. What is the difference between the highest and the lowest Imports (BoP, current US$) of Swaziland?
Your answer should be compact. 6.38e+08. 